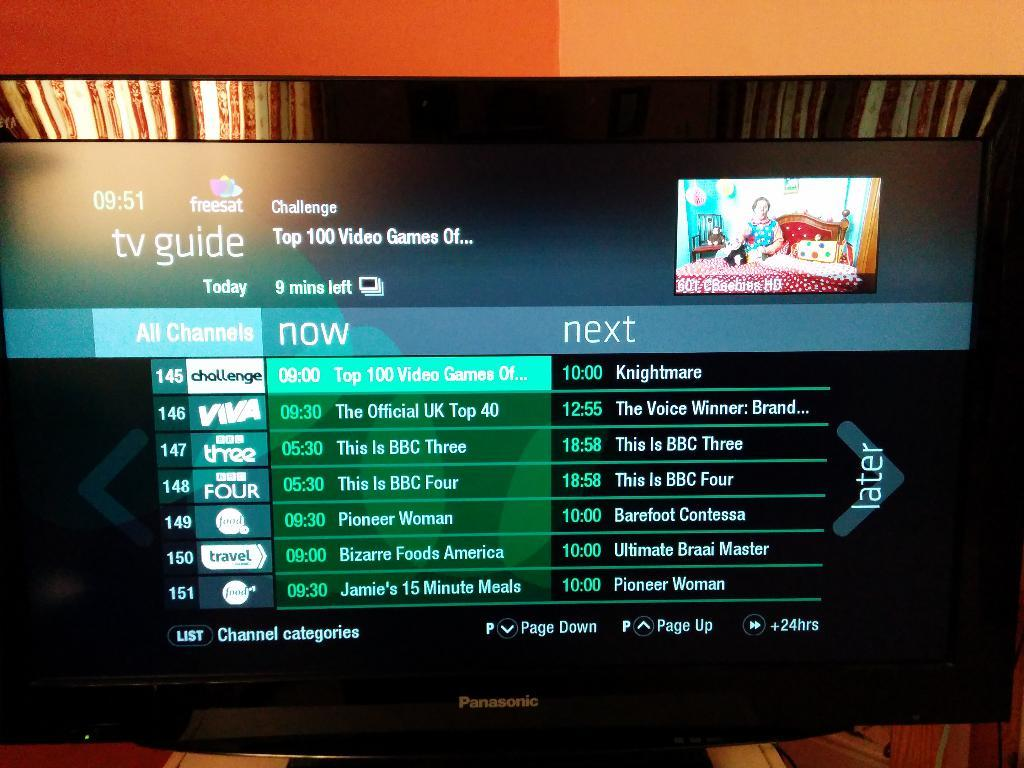<image>
Provide a brief description of the given image. A digital TV guide is pictured on a large TV screen. 